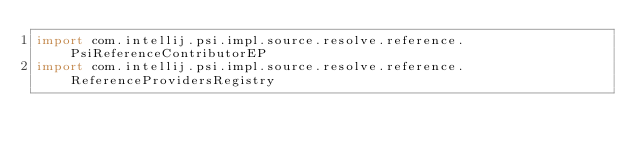<code> <loc_0><loc_0><loc_500><loc_500><_Kotlin_>import com.intellij.psi.impl.source.resolve.reference.PsiReferenceContributorEP
import com.intellij.psi.impl.source.resolve.reference.ReferenceProvidersRegistry</code> 